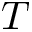Convert formula to latex. <formula><loc_0><loc_0><loc_500><loc_500>T</formula> 